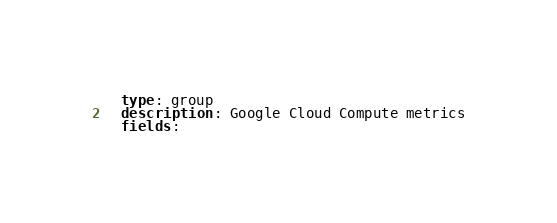Convert code to text. <code><loc_0><loc_0><loc_500><loc_500><_YAML_>  type: group
  description: Google Cloud Compute metrics
  fields:
</code> 